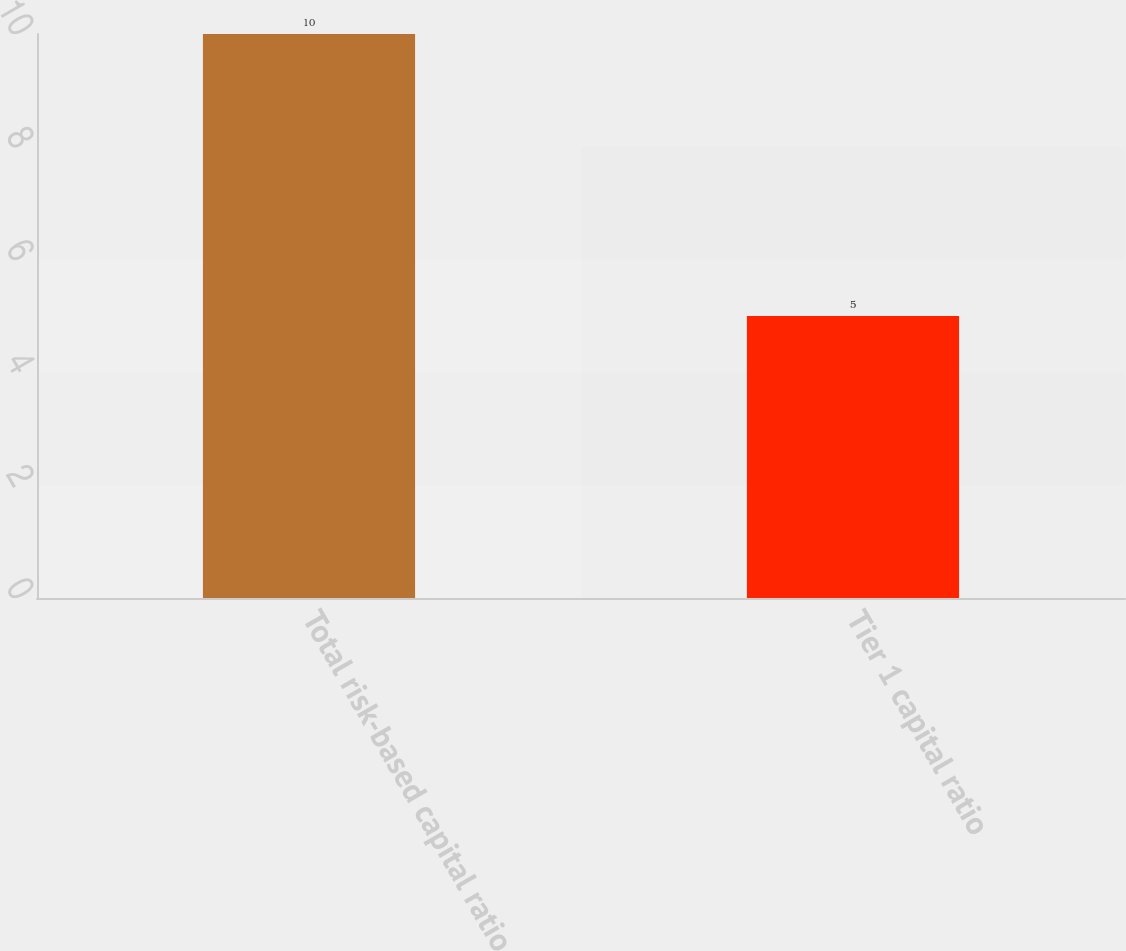<chart> <loc_0><loc_0><loc_500><loc_500><bar_chart><fcel>Total risk-based capital ratio<fcel>Tier 1 capital ratio<nl><fcel>10<fcel>5<nl></chart> 